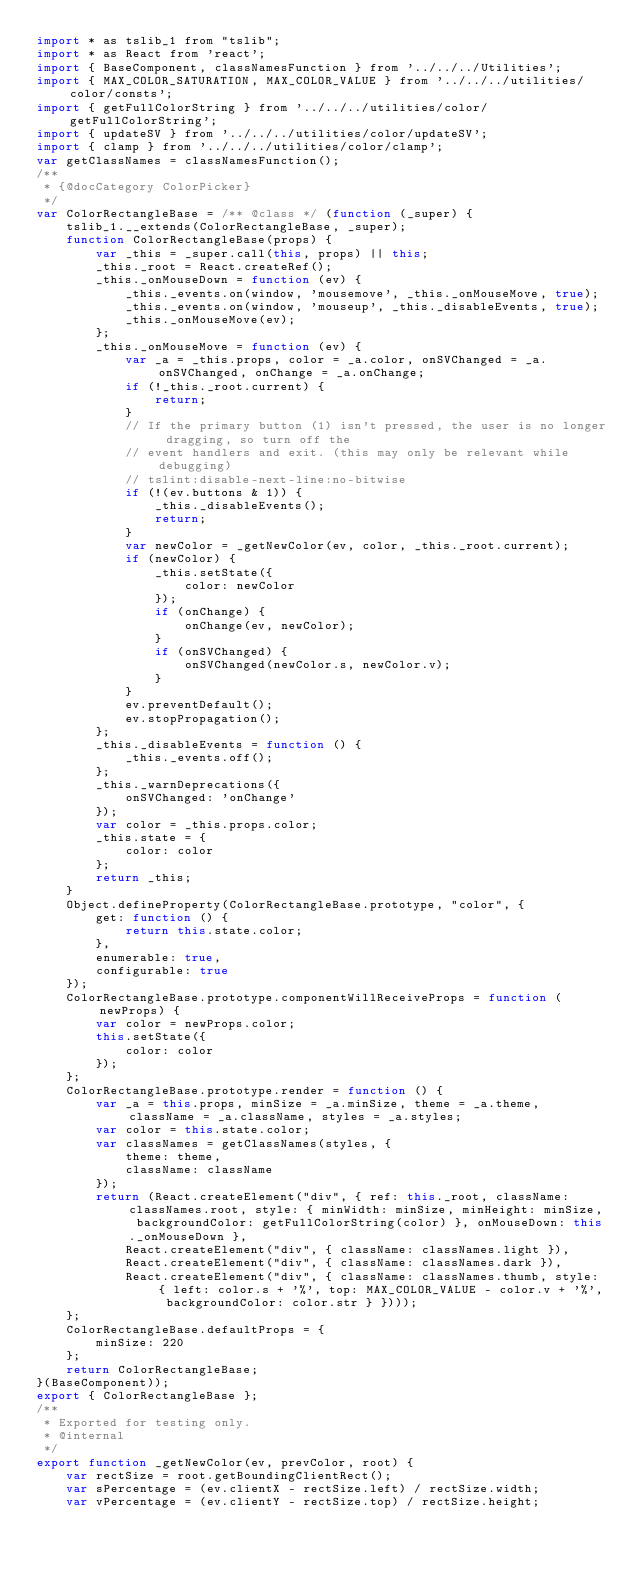Convert code to text. <code><loc_0><loc_0><loc_500><loc_500><_JavaScript_>import * as tslib_1 from "tslib";
import * as React from 'react';
import { BaseComponent, classNamesFunction } from '../../../Utilities';
import { MAX_COLOR_SATURATION, MAX_COLOR_VALUE } from '../../../utilities/color/consts';
import { getFullColorString } from '../../../utilities/color/getFullColorString';
import { updateSV } from '../../../utilities/color/updateSV';
import { clamp } from '../../../utilities/color/clamp';
var getClassNames = classNamesFunction();
/**
 * {@docCategory ColorPicker}
 */
var ColorRectangleBase = /** @class */ (function (_super) {
    tslib_1.__extends(ColorRectangleBase, _super);
    function ColorRectangleBase(props) {
        var _this = _super.call(this, props) || this;
        _this._root = React.createRef();
        _this._onMouseDown = function (ev) {
            _this._events.on(window, 'mousemove', _this._onMouseMove, true);
            _this._events.on(window, 'mouseup', _this._disableEvents, true);
            _this._onMouseMove(ev);
        };
        _this._onMouseMove = function (ev) {
            var _a = _this.props, color = _a.color, onSVChanged = _a.onSVChanged, onChange = _a.onChange;
            if (!_this._root.current) {
                return;
            }
            // If the primary button (1) isn't pressed, the user is no longer dragging, so turn off the
            // event handlers and exit. (this may only be relevant while debugging)
            // tslint:disable-next-line:no-bitwise
            if (!(ev.buttons & 1)) {
                _this._disableEvents();
                return;
            }
            var newColor = _getNewColor(ev, color, _this._root.current);
            if (newColor) {
                _this.setState({
                    color: newColor
                });
                if (onChange) {
                    onChange(ev, newColor);
                }
                if (onSVChanged) {
                    onSVChanged(newColor.s, newColor.v);
                }
            }
            ev.preventDefault();
            ev.stopPropagation();
        };
        _this._disableEvents = function () {
            _this._events.off();
        };
        _this._warnDeprecations({
            onSVChanged: 'onChange'
        });
        var color = _this.props.color;
        _this.state = {
            color: color
        };
        return _this;
    }
    Object.defineProperty(ColorRectangleBase.prototype, "color", {
        get: function () {
            return this.state.color;
        },
        enumerable: true,
        configurable: true
    });
    ColorRectangleBase.prototype.componentWillReceiveProps = function (newProps) {
        var color = newProps.color;
        this.setState({
            color: color
        });
    };
    ColorRectangleBase.prototype.render = function () {
        var _a = this.props, minSize = _a.minSize, theme = _a.theme, className = _a.className, styles = _a.styles;
        var color = this.state.color;
        var classNames = getClassNames(styles, {
            theme: theme,
            className: className
        });
        return (React.createElement("div", { ref: this._root, className: classNames.root, style: { minWidth: minSize, minHeight: minSize, backgroundColor: getFullColorString(color) }, onMouseDown: this._onMouseDown },
            React.createElement("div", { className: classNames.light }),
            React.createElement("div", { className: classNames.dark }),
            React.createElement("div", { className: classNames.thumb, style: { left: color.s + '%', top: MAX_COLOR_VALUE - color.v + '%', backgroundColor: color.str } })));
    };
    ColorRectangleBase.defaultProps = {
        minSize: 220
    };
    return ColorRectangleBase;
}(BaseComponent));
export { ColorRectangleBase };
/**
 * Exported for testing only.
 * @internal
 */
export function _getNewColor(ev, prevColor, root) {
    var rectSize = root.getBoundingClientRect();
    var sPercentage = (ev.clientX - rectSize.left) / rectSize.width;
    var vPercentage = (ev.clientY - rectSize.top) / rectSize.height;</code> 